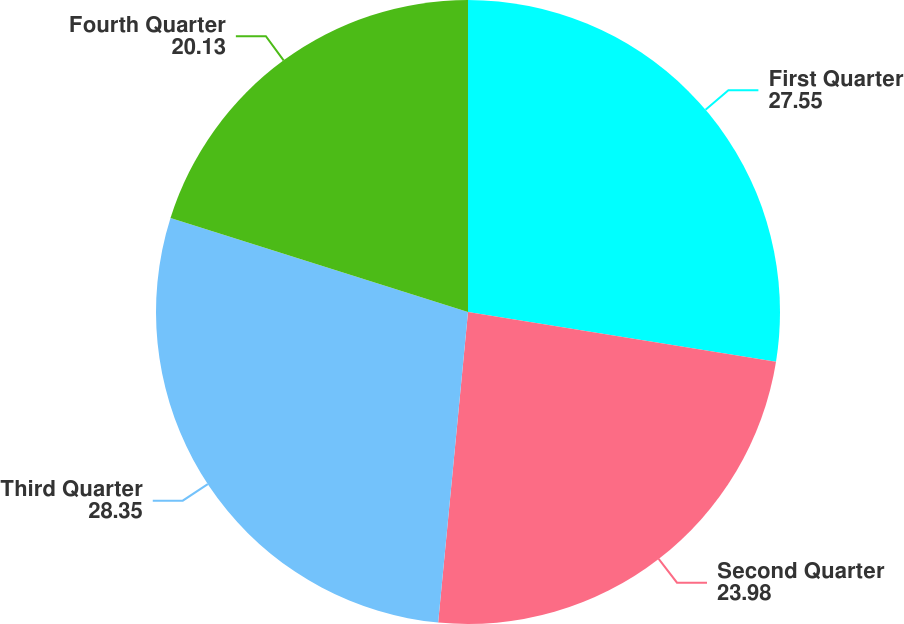Convert chart to OTSL. <chart><loc_0><loc_0><loc_500><loc_500><pie_chart><fcel>First Quarter<fcel>Second Quarter<fcel>Third Quarter<fcel>Fourth Quarter<nl><fcel>27.55%<fcel>23.98%<fcel>28.35%<fcel>20.13%<nl></chart> 